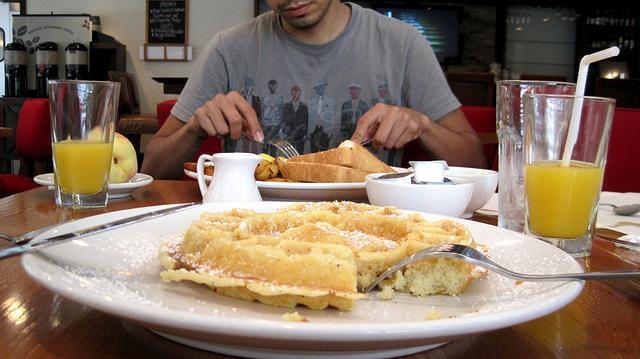How many cups are there?
Give a very brief answer. 3. How many chairs are in the photo?
Give a very brief answer. 2. 